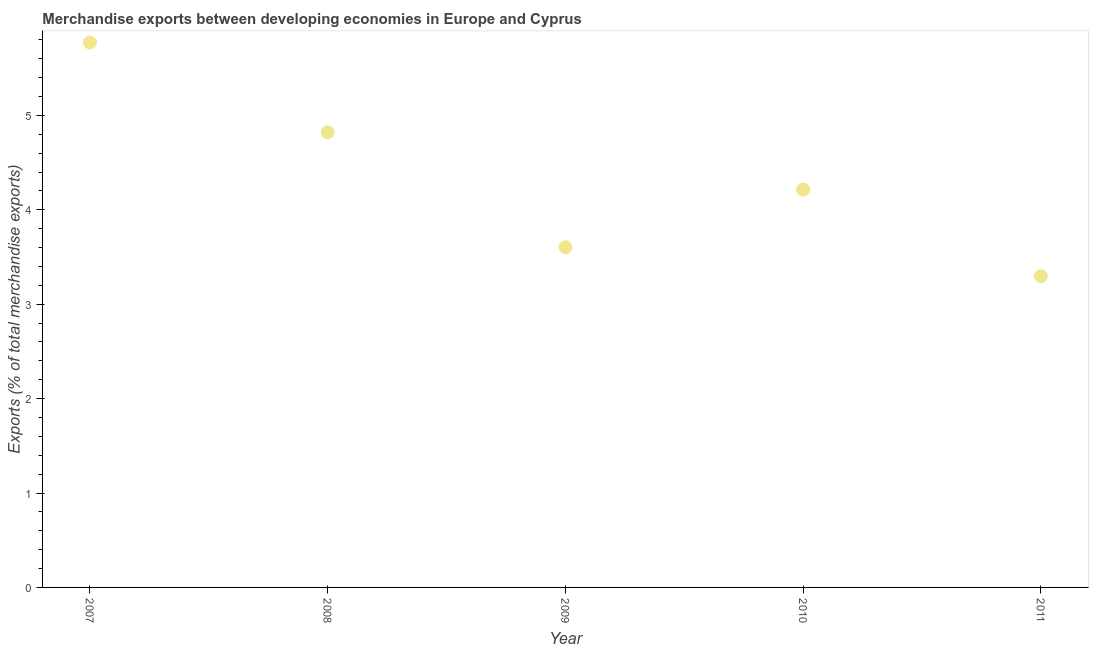What is the merchandise exports in 2010?
Your answer should be compact. 4.21. Across all years, what is the maximum merchandise exports?
Provide a short and direct response. 5.77. Across all years, what is the minimum merchandise exports?
Offer a very short reply. 3.3. In which year was the merchandise exports maximum?
Your answer should be compact. 2007. What is the sum of the merchandise exports?
Ensure brevity in your answer.  21.71. What is the difference between the merchandise exports in 2008 and 2009?
Give a very brief answer. 1.22. What is the average merchandise exports per year?
Give a very brief answer. 4.34. What is the median merchandise exports?
Your answer should be compact. 4.21. In how many years, is the merchandise exports greater than 4.8 %?
Offer a very short reply. 2. Do a majority of the years between 2009 and 2010 (inclusive) have merchandise exports greater than 0.4 %?
Ensure brevity in your answer.  Yes. What is the ratio of the merchandise exports in 2008 to that in 2011?
Your answer should be very brief. 1.46. What is the difference between the highest and the second highest merchandise exports?
Give a very brief answer. 0.95. Is the sum of the merchandise exports in 2010 and 2011 greater than the maximum merchandise exports across all years?
Your answer should be compact. Yes. What is the difference between the highest and the lowest merchandise exports?
Your response must be concise. 2.48. In how many years, is the merchandise exports greater than the average merchandise exports taken over all years?
Give a very brief answer. 2. Does the merchandise exports monotonically increase over the years?
Keep it short and to the point. No. What is the title of the graph?
Make the answer very short. Merchandise exports between developing economies in Europe and Cyprus. What is the label or title of the X-axis?
Your answer should be compact. Year. What is the label or title of the Y-axis?
Your answer should be very brief. Exports (% of total merchandise exports). What is the Exports (% of total merchandise exports) in 2007?
Provide a short and direct response. 5.77. What is the Exports (% of total merchandise exports) in 2008?
Offer a terse response. 4.82. What is the Exports (% of total merchandise exports) in 2009?
Your response must be concise. 3.6. What is the Exports (% of total merchandise exports) in 2010?
Your answer should be compact. 4.21. What is the Exports (% of total merchandise exports) in 2011?
Provide a succinct answer. 3.3. What is the difference between the Exports (% of total merchandise exports) in 2007 and 2008?
Offer a terse response. 0.95. What is the difference between the Exports (% of total merchandise exports) in 2007 and 2009?
Offer a terse response. 2.17. What is the difference between the Exports (% of total merchandise exports) in 2007 and 2010?
Provide a short and direct response. 1.56. What is the difference between the Exports (% of total merchandise exports) in 2007 and 2011?
Ensure brevity in your answer.  2.48. What is the difference between the Exports (% of total merchandise exports) in 2008 and 2009?
Your response must be concise. 1.22. What is the difference between the Exports (% of total merchandise exports) in 2008 and 2010?
Offer a terse response. 0.61. What is the difference between the Exports (% of total merchandise exports) in 2008 and 2011?
Provide a short and direct response. 1.52. What is the difference between the Exports (% of total merchandise exports) in 2009 and 2010?
Ensure brevity in your answer.  -0.61. What is the difference between the Exports (% of total merchandise exports) in 2009 and 2011?
Your response must be concise. 0.31. What is the difference between the Exports (% of total merchandise exports) in 2010 and 2011?
Keep it short and to the point. 0.92. What is the ratio of the Exports (% of total merchandise exports) in 2007 to that in 2008?
Provide a succinct answer. 1.2. What is the ratio of the Exports (% of total merchandise exports) in 2007 to that in 2009?
Keep it short and to the point. 1.6. What is the ratio of the Exports (% of total merchandise exports) in 2007 to that in 2010?
Ensure brevity in your answer.  1.37. What is the ratio of the Exports (% of total merchandise exports) in 2007 to that in 2011?
Make the answer very short. 1.75. What is the ratio of the Exports (% of total merchandise exports) in 2008 to that in 2009?
Your answer should be very brief. 1.34. What is the ratio of the Exports (% of total merchandise exports) in 2008 to that in 2010?
Your answer should be compact. 1.14. What is the ratio of the Exports (% of total merchandise exports) in 2008 to that in 2011?
Give a very brief answer. 1.46. What is the ratio of the Exports (% of total merchandise exports) in 2009 to that in 2010?
Your answer should be compact. 0.85. What is the ratio of the Exports (% of total merchandise exports) in 2009 to that in 2011?
Your response must be concise. 1.09. What is the ratio of the Exports (% of total merchandise exports) in 2010 to that in 2011?
Your answer should be very brief. 1.28. 